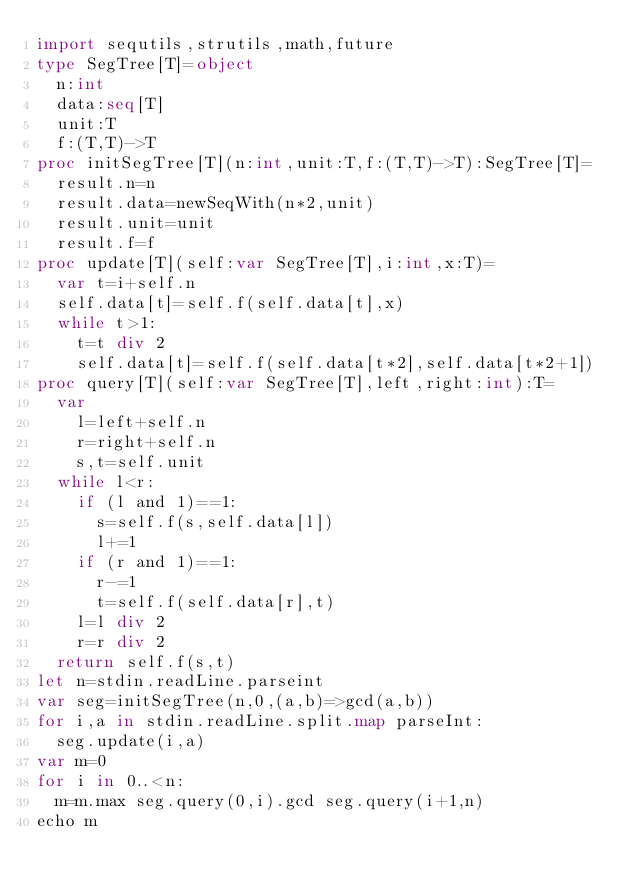Convert code to text. <code><loc_0><loc_0><loc_500><loc_500><_Nim_>import sequtils,strutils,math,future
type SegTree[T]=object
  n:int
  data:seq[T]
  unit:T
  f:(T,T)->T
proc initSegTree[T](n:int,unit:T,f:(T,T)->T):SegTree[T]=
  result.n=n
  result.data=newSeqWith(n*2,unit)
  result.unit=unit
  result.f=f
proc update[T](self:var SegTree[T],i:int,x:T)=
  var t=i+self.n
  self.data[t]=self.f(self.data[t],x)
  while t>1:
    t=t div 2
    self.data[t]=self.f(self.data[t*2],self.data[t*2+1])
proc query[T](self:var SegTree[T],left,right:int):T=
  var
    l=left+self.n
    r=right+self.n
    s,t=self.unit
  while l<r:
    if (l and 1)==1:
      s=self.f(s,self.data[l])
      l+=1
    if (r and 1)==1:
      r-=1
      t=self.f(self.data[r],t)
    l=l div 2
    r=r div 2
  return self.f(s,t)
let n=stdin.readLine.parseint
var seg=initSegTree(n,0,(a,b)=>gcd(a,b))
for i,a in stdin.readLine.split.map parseInt:
  seg.update(i,a)
var m=0
for i in 0..<n:
  m=m.max seg.query(0,i).gcd seg.query(i+1,n)
echo m</code> 